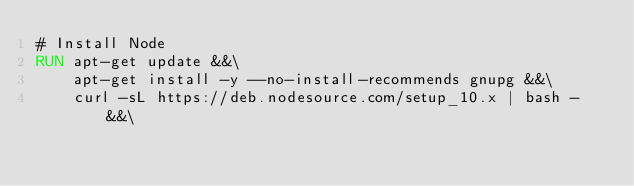Convert code to text. <code><loc_0><loc_0><loc_500><loc_500><_Dockerfile_># Install Node
RUN apt-get update &&\
    apt-get install -y --no-install-recommends gnupg &&\
    curl -sL https://deb.nodesource.com/setup_10.x | bash - &&\</code> 